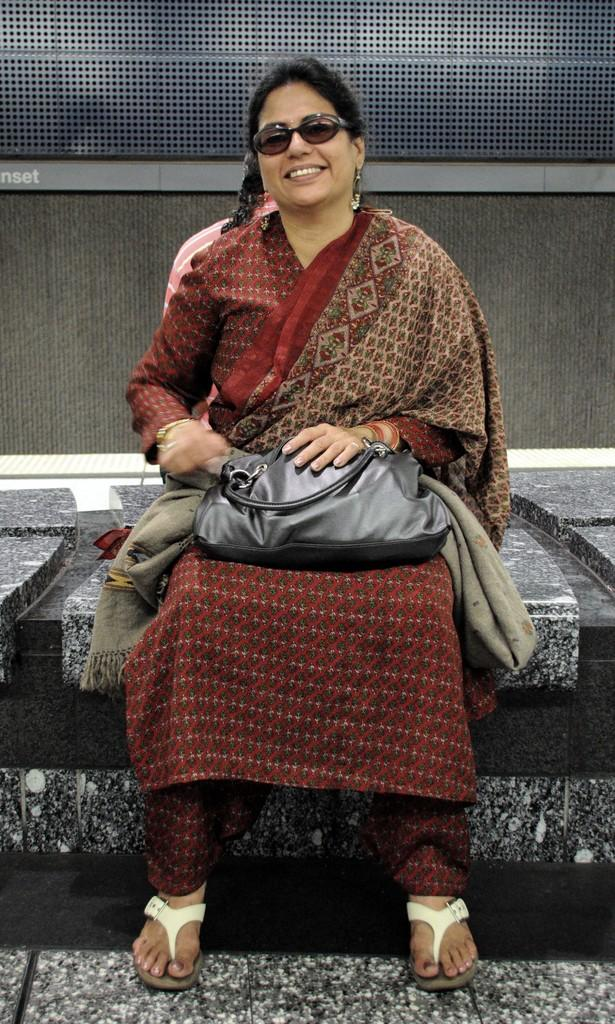Who is the main subject in the image? There is a woman in the image. What is the woman doing in the image? The woman is sitting on a bench. What is the woman's facial expression in the image? The woman is smiling. What is the woman wearing in the image? The woman is wearing a red dress. What accessory is the woman carrying in the image? The woman is carrying a black handbag. What can be seen in the background of the image? There is a wall in the background of the image. What type of cream is being applied to the woman's nose in the image? There is no cream being applied to the woman's nose in the image. What is the friction level between the woman and the bench in the image? The image does not provide information about the friction level between the woman and the bench. 